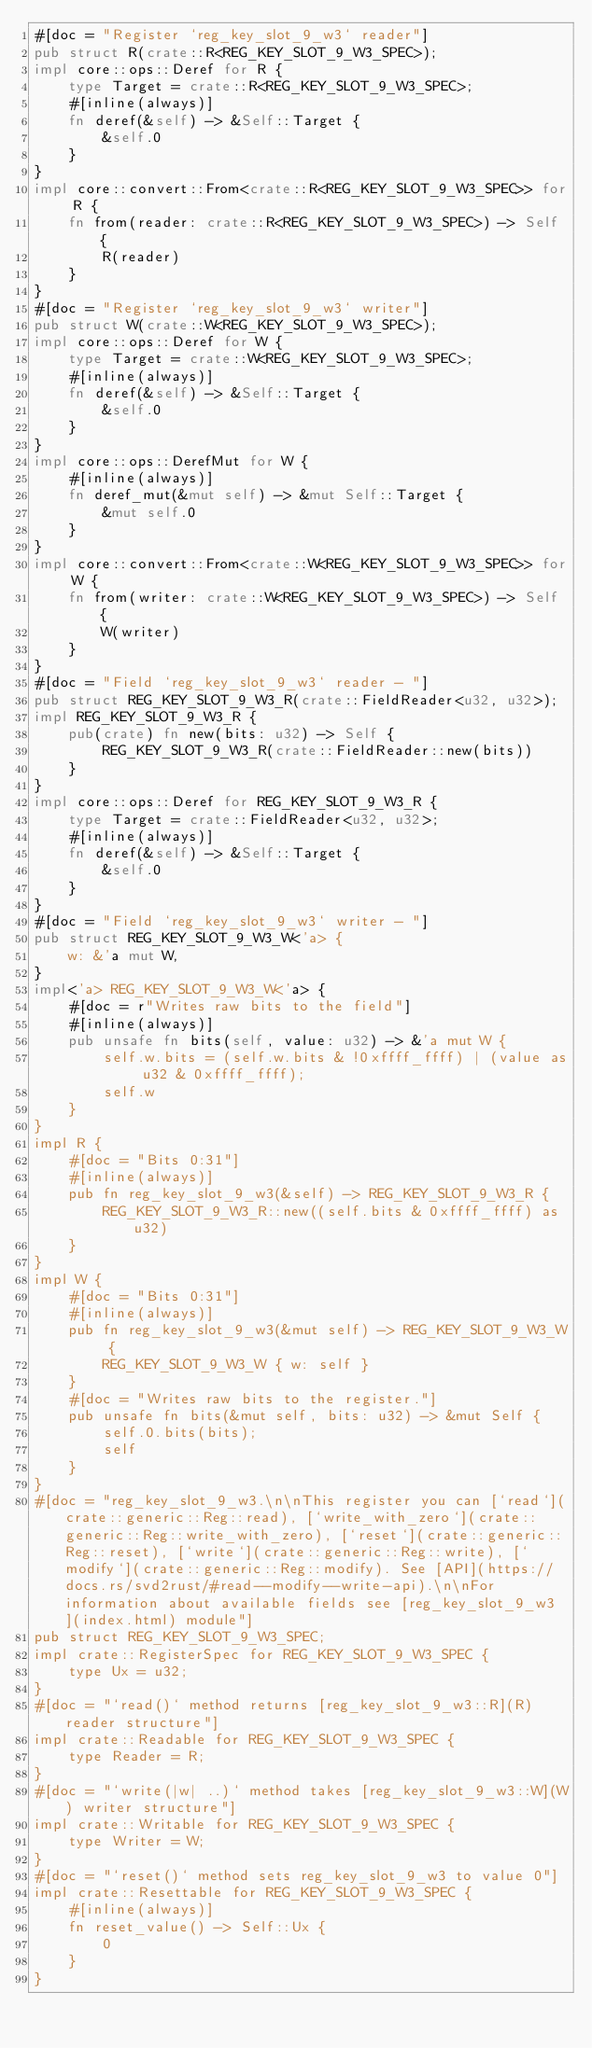<code> <loc_0><loc_0><loc_500><loc_500><_Rust_>#[doc = "Register `reg_key_slot_9_w3` reader"]
pub struct R(crate::R<REG_KEY_SLOT_9_W3_SPEC>);
impl core::ops::Deref for R {
    type Target = crate::R<REG_KEY_SLOT_9_W3_SPEC>;
    #[inline(always)]
    fn deref(&self) -> &Self::Target {
        &self.0
    }
}
impl core::convert::From<crate::R<REG_KEY_SLOT_9_W3_SPEC>> for R {
    fn from(reader: crate::R<REG_KEY_SLOT_9_W3_SPEC>) -> Self {
        R(reader)
    }
}
#[doc = "Register `reg_key_slot_9_w3` writer"]
pub struct W(crate::W<REG_KEY_SLOT_9_W3_SPEC>);
impl core::ops::Deref for W {
    type Target = crate::W<REG_KEY_SLOT_9_W3_SPEC>;
    #[inline(always)]
    fn deref(&self) -> &Self::Target {
        &self.0
    }
}
impl core::ops::DerefMut for W {
    #[inline(always)]
    fn deref_mut(&mut self) -> &mut Self::Target {
        &mut self.0
    }
}
impl core::convert::From<crate::W<REG_KEY_SLOT_9_W3_SPEC>> for W {
    fn from(writer: crate::W<REG_KEY_SLOT_9_W3_SPEC>) -> Self {
        W(writer)
    }
}
#[doc = "Field `reg_key_slot_9_w3` reader - "]
pub struct REG_KEY_SLOT_9_W3_R(crate::FieldReader<u32, u32>);
impl REG_KEY_SLOT_9_W3_R {
    pub(crate) fn new(bits: u32) -> Self {
        REG_KEY_SLOT_9_W3_R(crate::FieldReader::new(bits))
    }
}
impl core::ops::Deref for REG_KEY_SLOT_9_W3_R {
    type Target = crate::FieldReader<u32, u32>;
    #[inline(always)]
    fn deref(&self) -> &Self::Target {
        &self.0
    }
}
#[doc = "Field `reg_key_slot_9_w3` writer - "]
pub struct REG_KEY_SLOT_9_W3_W<'a> {
    w: &'a mut W,
}
impl<'a> REG_KEY_SLOT_9_W3_W<'a> {
    #[doc = r"Writes raw bits to the field"]
    #[inline(always)]
    pub unsafe fn bits(self, value: u32) -> &'a mut W {
        self.w.bits = (self.w.bits & !0xffff_ffff) | (value as u32 & 0xffff_ffff);
        self.w
    }
}
impl R {
    #[doc = "Bits 0:31"]
    #[inline(always)]
    pub fn reg_key_slot_9_w3(&self) -> REG_KEY_SLOT_9_W3_R {
        REG_KEY_SLOT_9_W3_R::new((self.bits & 0xffff_ffff) as u32)
    }
}
impl W {
    #[doc = "Bits 0:31"]
    #[inline(always)]
    pub fn reg_key_slot_9_w3(&mut self) -> REG_KEY_SLOT_9_W3_W {
        REG_KEY_SLOT_9_W3_W { w: self }
    }
    #[doc = "Writes raw bits to the register."]
    pub unsafe fn bits(&mut self, bits: u32) -> &mut Self {
        self.0.bits(bits);
        self
    }
}
#[doc = "reg_key_slot_9_w3.\n\nThis register you can [`read`](crate::generic::Reg::read), [`write_with_zero`](crate::generic::Reg::write_with_zero), [`reset`](crate::generic::Reg::reset), [`write`](crate::generic::Reg::write), [`modify`](crate::generic::Reg::modify). See [API](https://docs.rs/svd2rust/#read--modify--write-api).\n\nFor information about available fields see [reg_key_slot_9_w3](index.html) module"]
pub struct REG_KEY_SLOT_9_W3_SPEC;
impl crate::RegisterSpec for REG_KEY_SLOT_9_W3_SPEC {
    type Ux = u32;
}
#[doc = "`read()` method returns [reg_key_slot_9_w3::R](R) reader structure"]
impl crate::Readable for REG_KEY_SLOT_9_W3_SPEC {
    type Reader = R;
}
#[doc = "`write(|w| ..)` method takes [reg_key_slot_9_w3::W](W) writer structure"]
impl crate::Writable for REG_KEY_SLOT_9_W3_SPEC {
    type Writer = W;
}
#[doc = "`reset()` method sets reg_key_slot_9_w3 to value 0"]
impl crate::Resettable for REG_KEY_SLOT_9_W3_SPEC {
    #[inline(always)]
    fn reset_value() -> Self::Ux {
        0
    }
}
</code> 